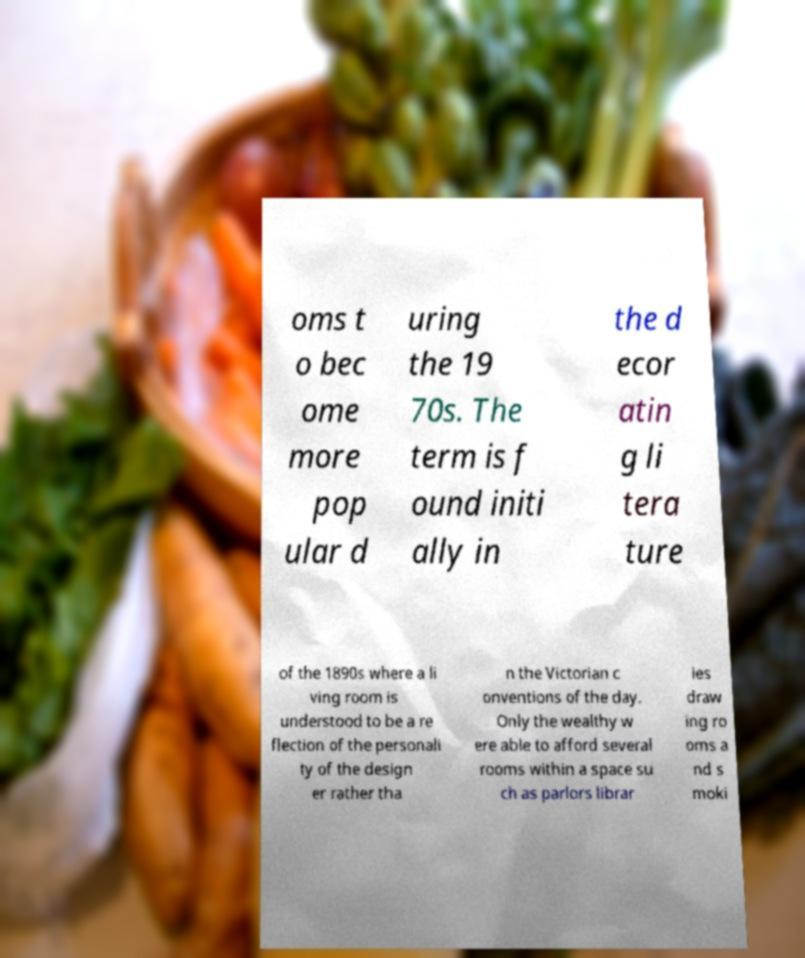What messages or text are displayed in this image? I need them in a readable, typed format. oms t o bec ome more pop ular d uring the 19 70s. The term is f ound initi ally in the d ecor atin g li tera ture of the 1890s where a li ving room is understood to be a re flection of the personali ty of the design er rather tha n the Victorian c onventions of the day. Only the wealthy w ere able to afford several rooms within a space su ch as parlors librar ies draw ing ro oms a nd s moki 